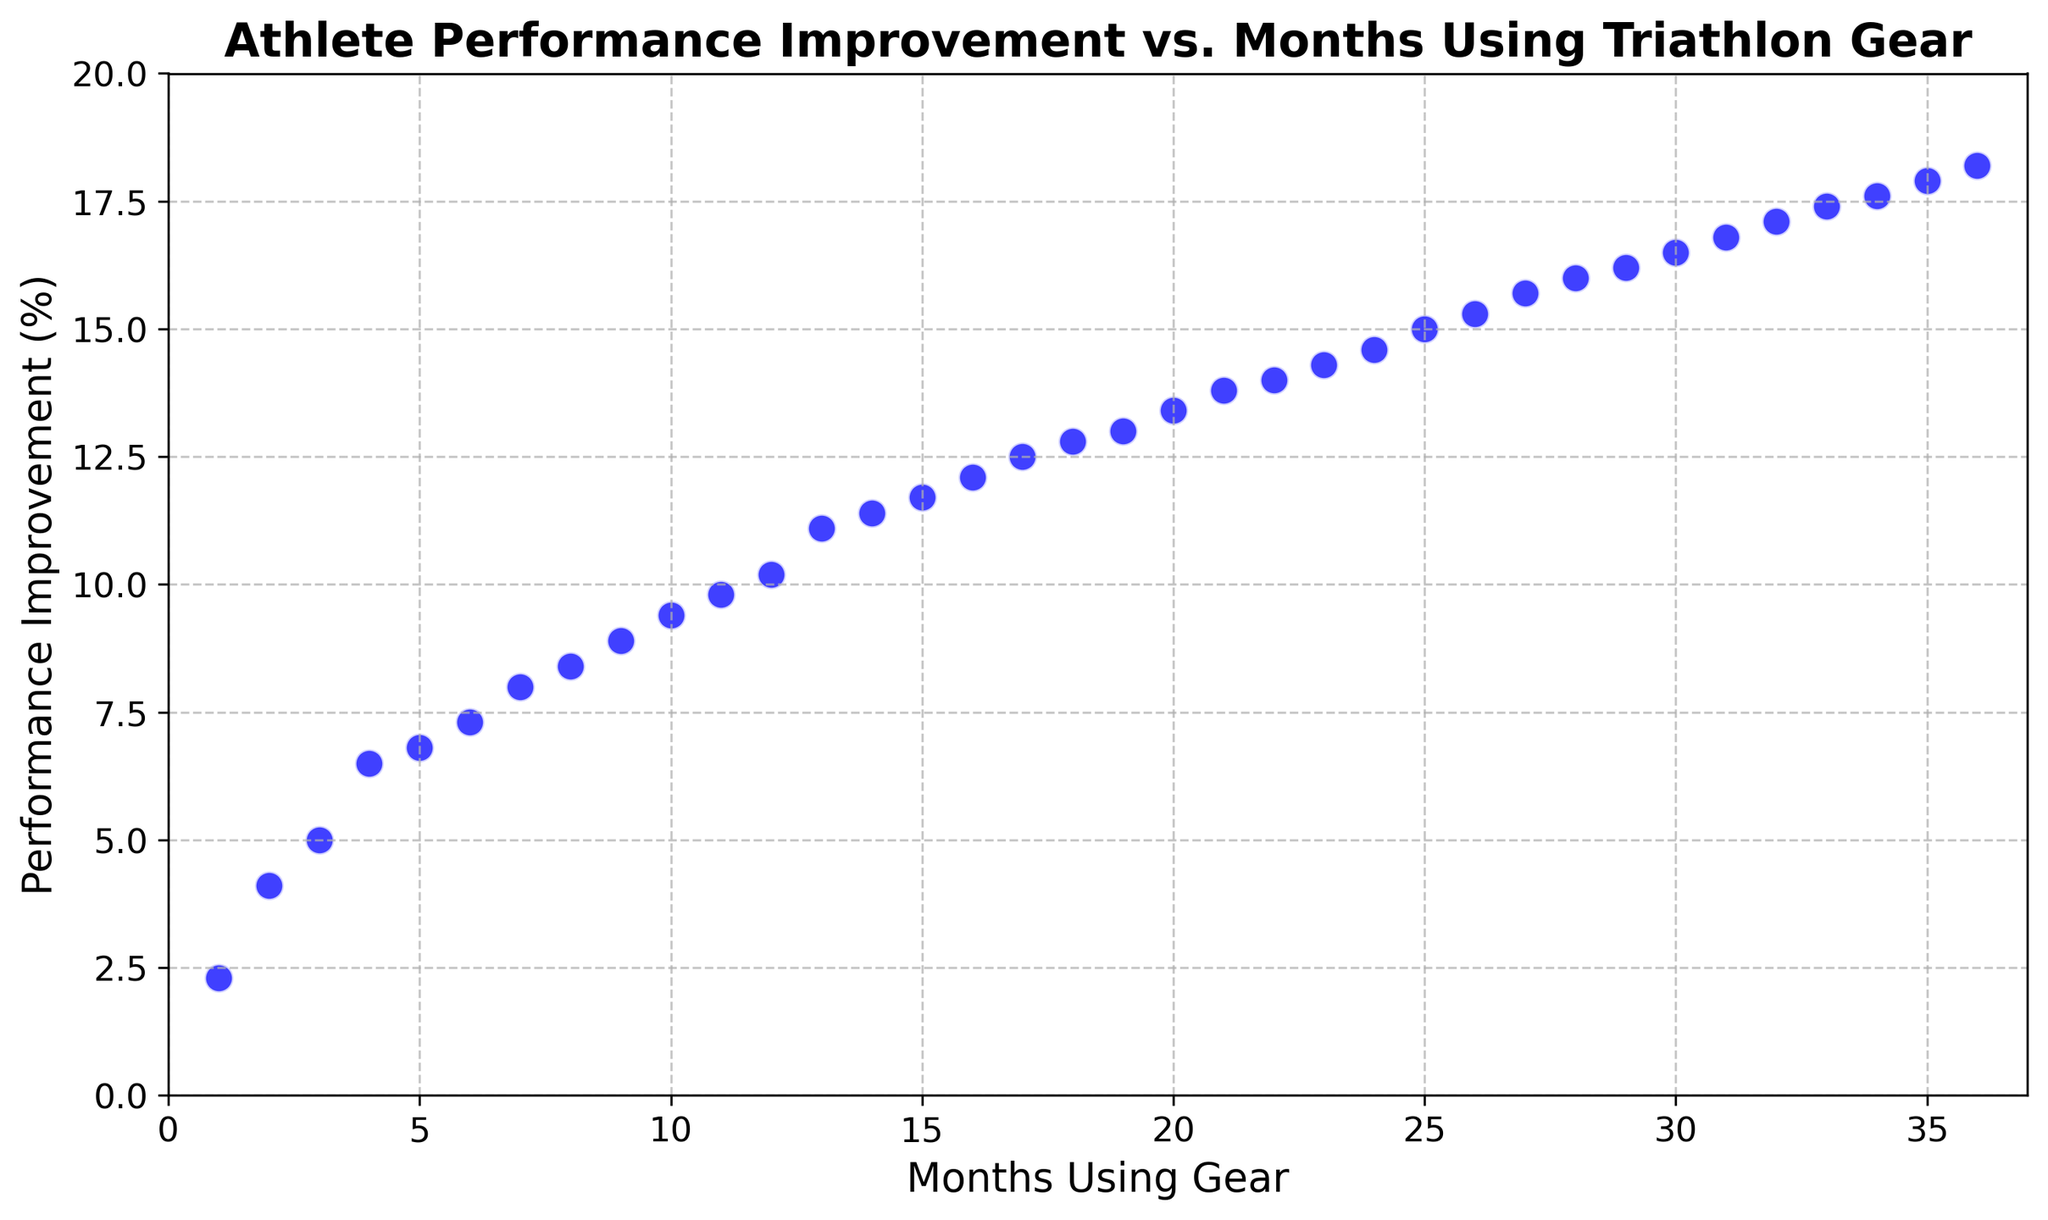What is the overall trend in athlete performance improvement over the months? By observing the scatter plot, all data points show a positive slope, indicating that performance improvement tends to increase as the months using the gear increase.
Answer: Increasing trend What is the performance improvement percentage at 12 months? Find the scatter point at 12 months on the x-axis and look up to the y-axis to find the corresponding performance improvement percentage, which is 10.2%.
Answer: 10.2% How does the performance improvement at 6 months compare to that at 18 months? Locate the points for 6 months and 18 months on the scatter plot. The performance improvement at 6 months is about 7.3%, and at 18 months, it is about 12.8%. Thus, improvement at 18 months is higher.
Answer: 18 months is higher What is the difference in performance improvement between 24 and 30 months? Find the performance improvement at 24 months (14.6%) and at 30 months (16.5%), and then calculate the difference (16.5 - 14.6 = 1.9).
Answer: 1.9% At which month does the performance improvement first exceed 10%? Identify the scatter point where the y-value first exceeds 10%. This happens at 12 months.
Answer: 12 months Is there any point where the performance improvement is exactly 15%? Scan through the scatter plot and find the point where the y-value is exactly 15%. This happens at 25 months.
Answer: 25 months Between which consecutive months is the largest improvement in performance observed? Compare the difference in performance improvement between consecutive scatter points. The largest jump is from 34 months to 35 months, where improvement goes from 17.6% to 17.9%, a difference of 0.3%.
Answer: Between 34 and 35 months What visual trait makes it easier to identify the trend in the scatter plot? The scatter points are connected with grid lines, and continual increase in y-values (vertical movement) reinforces the trend illustration.
Answer: Grid lines and increasing y-values What is the average performance improvement over the first 6 months? Add up the performance improvement percentages for the first 6 months (2.3 + 4.1 + 5.0 + 6.5 + 6.8 + 7.3 = 32) and divide by 6 to obtain the average (32/6 ≈ 5.33%).
Answer: 5.33% How many months did it take for the performance improvement to double from its initial value? The initial performance improvement at 1 month is 2.3%. Doubling this value is 4.6%. Look for the closest scatter point exceeding 4.6%, which occurs at 2 months with 4.1%, so we consider 3 months with 5.0% as the next point doubling the initial value.
Answer: 3 months 